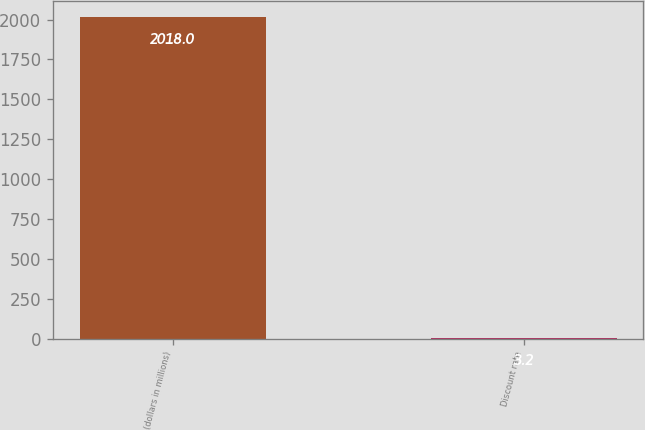Convert chart to OTSL. <chart><loc_0><loc_0><loc_500><loc_500><bar_chart><fcel>(dollars in millions)<fcel>Discount rate<nl><fcel>2018<fcel>3.2<nl></chart> 